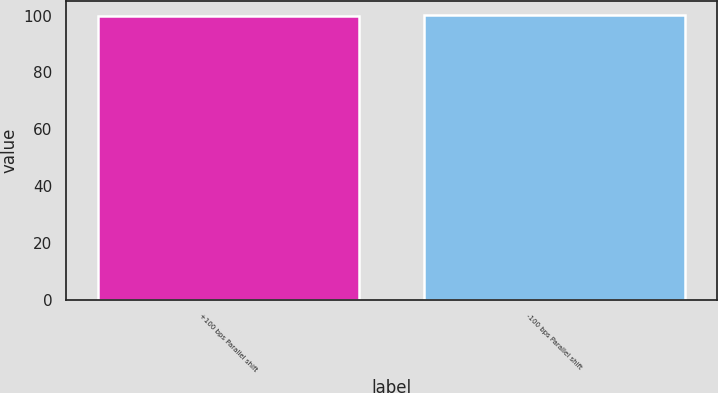Convert chart to OTSL. <chart><loc_0><loc_0><loc_500><loc_500><bar_chart><fcel>+100 bps Parallel shift<fcel>-100 bps Parallel shift<nl><fcel>100<fcel>100.1<nl></chart> 